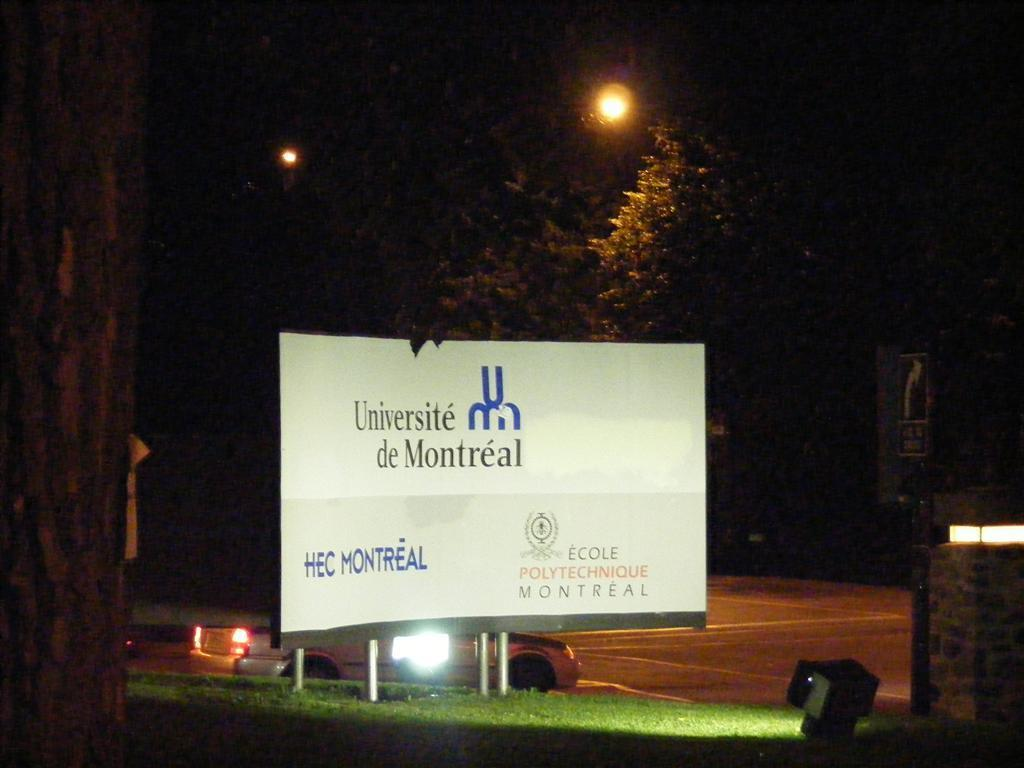Provide a one-sentence caption for the provided image. The billboard for Universite de Montreal is brightly lit in a dark parking lot. 